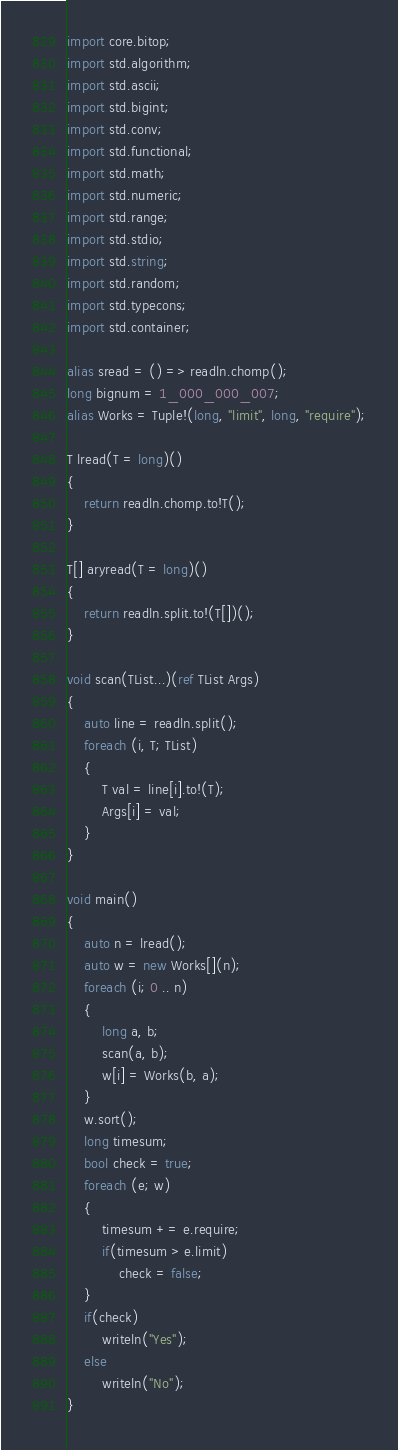Convert code to text. <code><loc_0><loc_0><loc_500><loc_500><_D_>import core.bitop;
import std.algorithm;
import std.ascii;
import std.bigint;
import std.conv;
import std.functional;
import std.math;
import std.numeric;
import std.range;
import std.stdio;
import std.string;
import std.random;
import std.typecons;
import std.container;

alias sread = () => readln.chomp();
long bignum = 1_000_000_007;
alias Works = Tuple!(long, "limit", long, "require");

T lread(T = long)()
{
    return readln.chomp.to!T();
}

T[] aryread(T = long)()
{
    return readln.split.to!(T[])();
}

void scan(TList...)(ref TList Args)
{
    auto line = readln.split();
    foreach (i, T; TList)
    {
        T val = line[i].to!(T);
        Args[i] = val;
    }
}

void main()
{
    auto n = lread();
    auto w = new Works[](n);
    foreach (i; 0 .. n)
    {
        long a, b;
        scan(a, b);
        w[i] = Works(b, a);
    }
    w.sort();
    long timesum;
    bool check = true;
    foreach (e; w)
    {
        timesum += e.require;
        if(timesum > e.limit)
            check = false;
    }
    if(check)
        writeln("Yes");
    else
        writeln("No");
}
</code> 